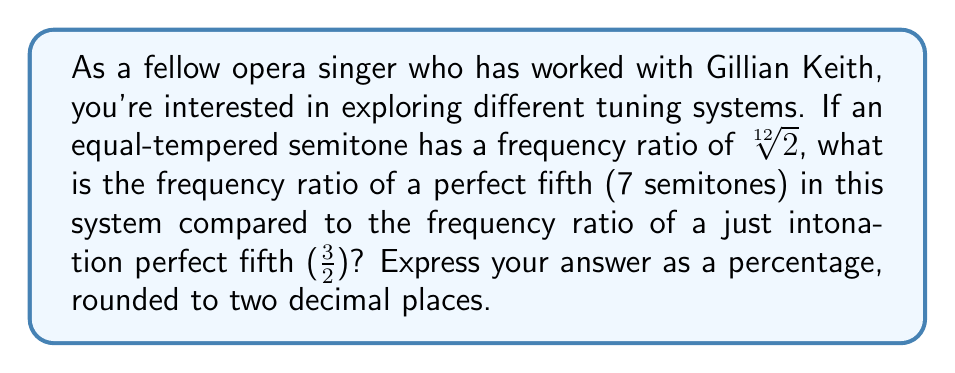Show me your answer to this math problem. To solve this problem, let's follow these steps:

1) In equal temperament, each semitone has a frequency ratio of $\sqrt[12]{2}$.

2) A perfect fifth is 7 semitones. So in equal temperament, its frequency ratio is:

   $$(\sqrt[12]{2})^7 = 2^{\frac{7}{12}} \approx 1.4983$$

3) In just intonation, a perfect fifth has a frequency ratio of $\frac{3}{2} = 1.5$

4) To compare these, we can divide the equal temperament ratio by the just intonation ratio:

   $$\frac{2^{\frac{7}{12}}}{\frac{3}{2}} = \frac{2^{\frac{7}{12}}}{\frac{3}{2}} \cdot \frac{2}{2} = \frac{2^{\frac{19}{12}}}{3} \approx 0.9989$$

5) To express this as a percentage, we multiply by 100:

   $$0.9989 \times 100 \approx 99.89\%$$

This means that the equal temperament perfect fifth is about 99.89% of the size of a just intonation perfect fifth.
Answer: 99.89% 